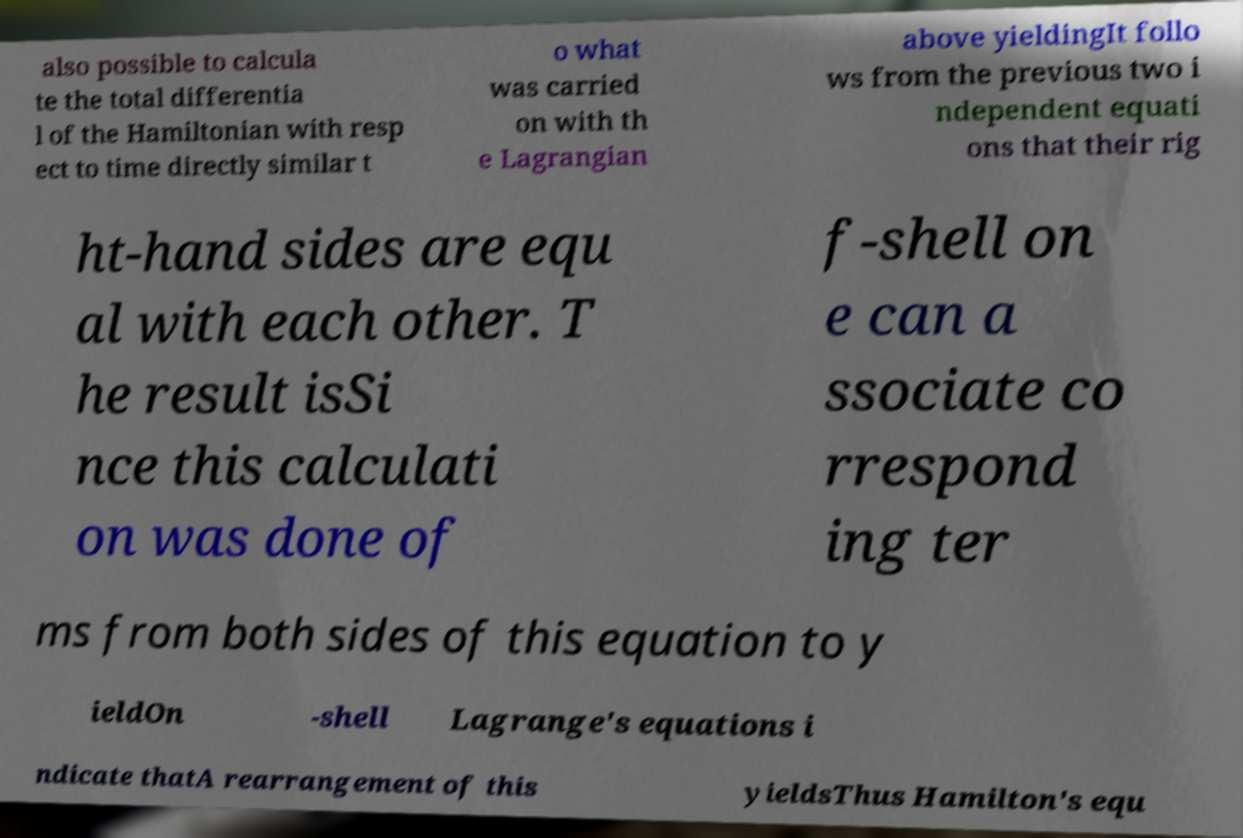There's text embedded in this image that I need extracted. Can you transcribe it verbatim? also possible to calcula te the total differentia l of the Hamiltonian with resp ect to time directly similar t o what was carried on with th e Lagrangian above yieldingIt follo ws from the previous two i ndependent equati ons that their rig ht-hand sides are equ al with each other. T he result isSi nce this calculati on was done of f-shell on e can a ssociate co rrespond ing ter ms from both sides of this equation to y ieldOn -shell Lagrange's equations i ndicate thatA rearrangement of this yieldsThus Hamilton's equ 